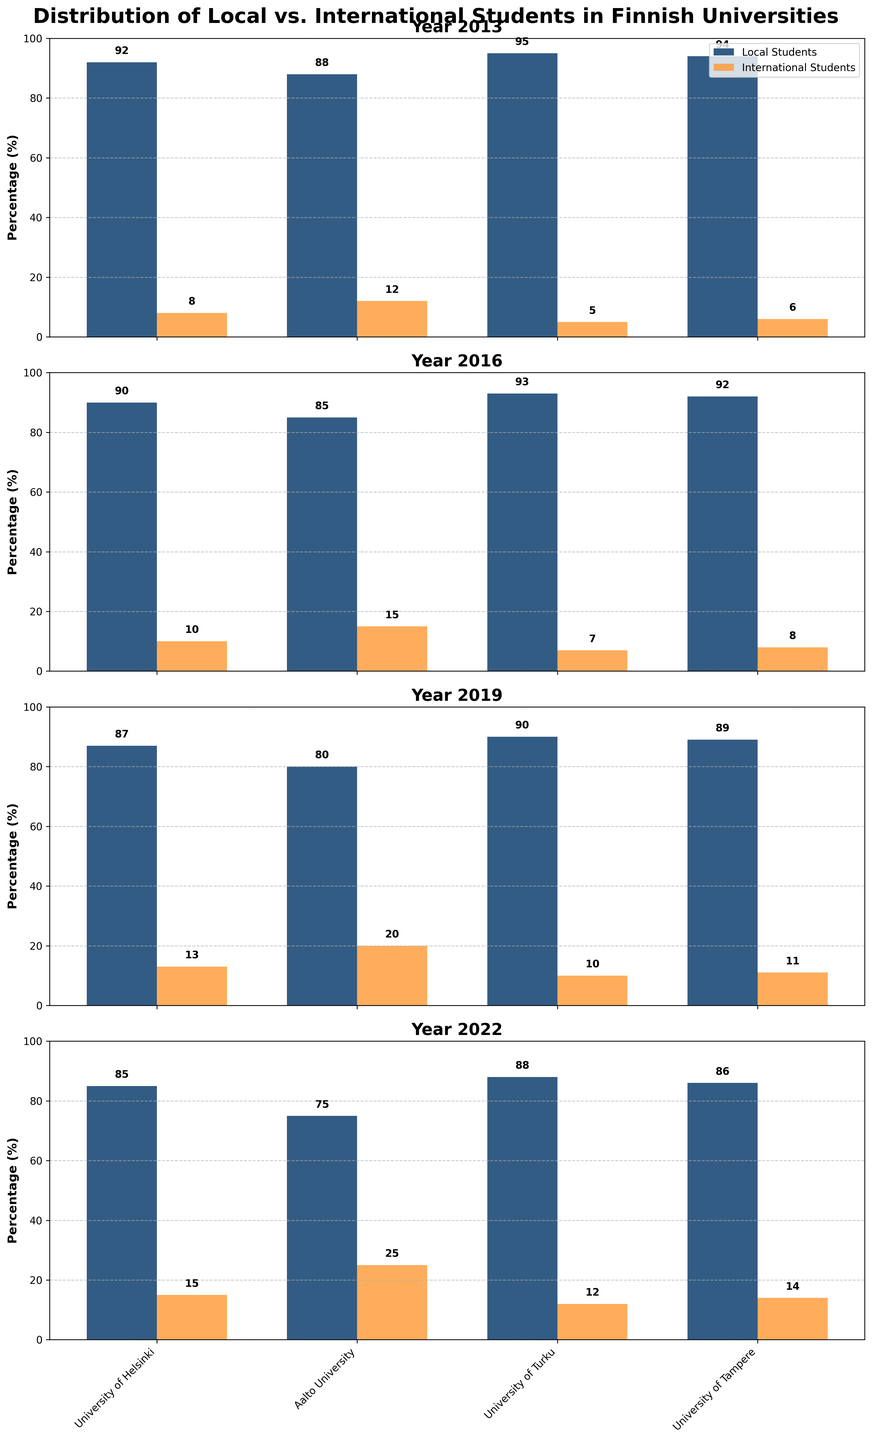Which university had the highest percentage of local students in 2022? Look at the 2022 subplot and compare the bar heights for local students. The University of Turku shows the highest percentage.
Answer: University of Turku How did the percentage of international students at Aalto University change from 2013 to 2022? Observe Aalto University's bars for international students across the subplots. They increased from 12% in 2013 to 25% in 2022.
Answer: Increased from 12% to 25% What was the total percentage of local and international students at the University of Tampere in 2019? For the University of Tampere in the 2019 subplot, sum the local (89%) and international (11%) percentages: 89% + 11% = 100%.
Answer: 100% Which university saw the largest increase in the percentage of international students between 2013 and 2022? Calculate the increase for each university by subtracting the 2013 percentage from the 2022 percentage. Aalto University increased by 13% (25% - 12%).
Answer: Aalto University Did any university have a constant percentage of local students over the decade? Compare local student percentages for each university in all subplots. None of the universities show a constant percentage throughout the years.
Answer: No Which university had the smallest percentage of international students in 2016? In the 2016 subplot, compare the international student percentages. The University of Turku had the smallest percentage at 7%.
Answer: University of Turku How did the percentage of local students at the University of Helsinki change over the years? Examine the University of Helsinki's local student percentages in each subplot: 92% (2013), 90% (2016), 87% (2019), 85% (2022).
Answer: Decreased In 2019, which had a higher percentage at the University of Turku: local or international students? Refer to the 2019 subplot and compare the bars for the University of Turku. The local student percentage (90%) is higher than international (10%).
Answer: Local students Calculate the average percentage of international students at the University of Tampere from 2013 to 2022. Sum international student percentages at the University of Tampere for each year: (6% + 8% + 11% + 14%) = 39%. Average = 39% / 4 = 9.75%.
Answer: 9.75% Which year had the highest overall percentage of international students across all universities? Sum the international percentages for all universities for each year and compare. The year 2022 has the highest sums indicating the highest overall percentage.
Answer: 2022 